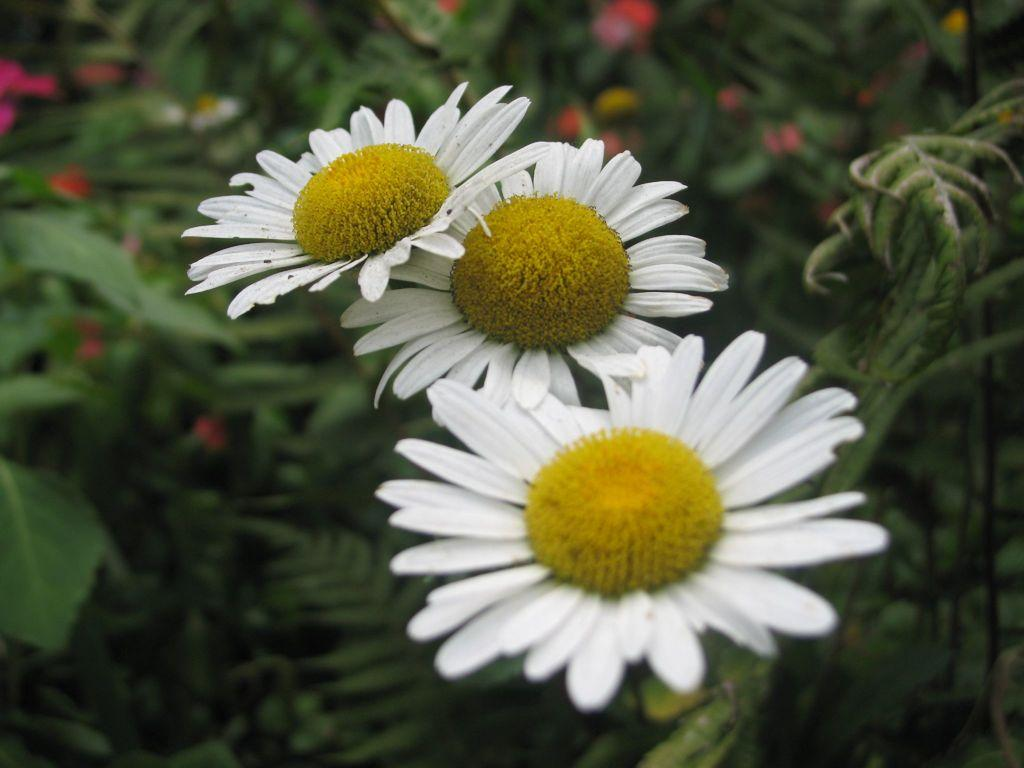How many sunflowers are in the image? There are three sunflowers in the image. What other types of flowers can be seen in the image? There are red flowers visible in the image. Where is the plant located in the image? The plant is on the left side of the image. What type of rhythm can be heard coming from the sunflowers in the image? There is no rhythm coming from the sunflowers in the image, as they are plants and do not produce sound. 